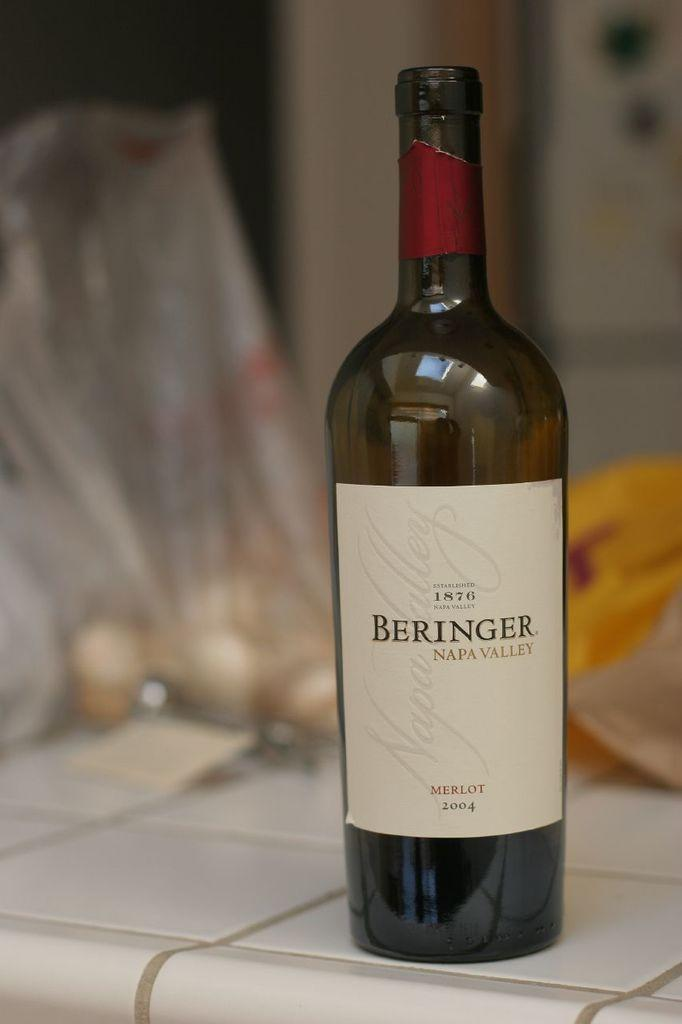<image>
Describe the image concisely. A bottle of wine with the word Beringer on the label. 